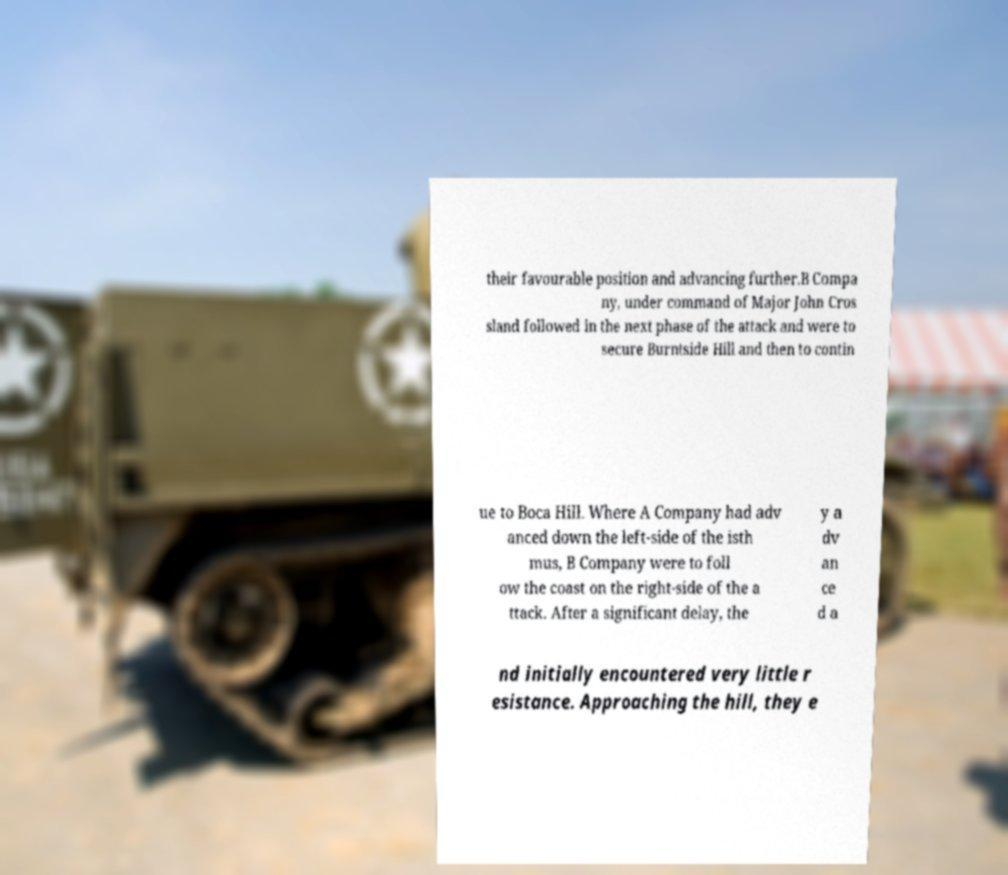Please identify and transcribe the text found in this image. their favourable position and advancing further.B Compa ny, under command of Major John Cros sland followed in the next phase of the attack and were to secure Burntside Hill and then to contin ue to Boca Hill. Where A Company had adv anced down the left-side of the isth mus, B Company were to foll ow the coast on the right-side of the a ttack. After a significant delay, the y a dv an ce d a nd initially encountered very little r esistance. Approaching the hill, they e 